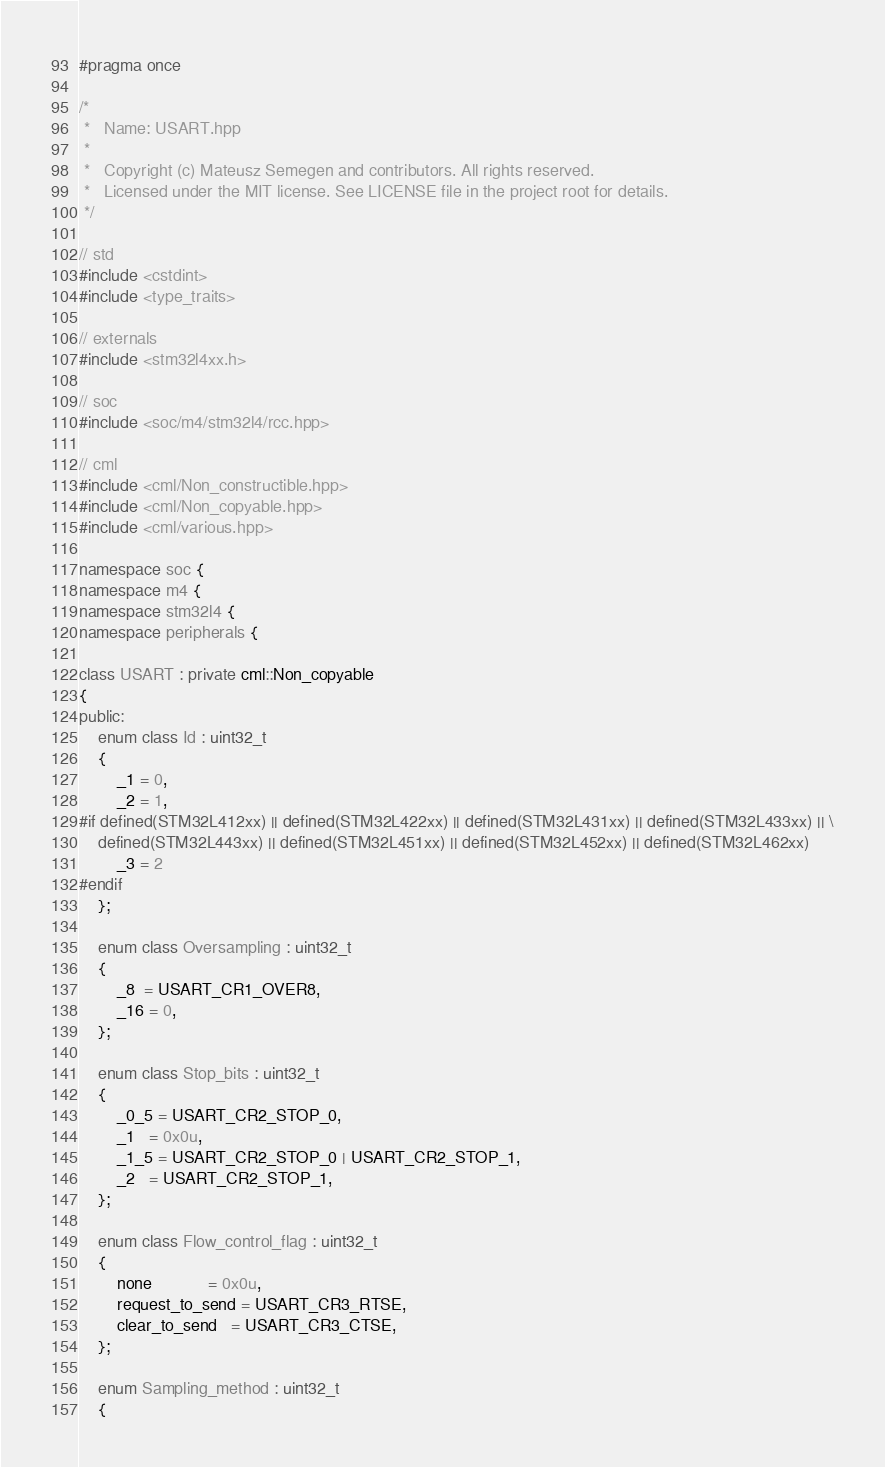Convert code to text. <code><loc_0><loc_0><loc_500><loc_500><_C++_>#pragma once

/*
 *   Name: USART.hpp
 *
 *   Copyright (c) Mateusz Semegen and contributors. All rights reserved.
 *   Licensed under the MIT license. See LICENSE file in the project root for details.
 */

// std
#include <cstdint>
#include <type_traits>

// externals
#include <stm32l4xx.h>

// soc
#include <soc/m4/stm32l4/rcc.hpp>

// cml
#include <cml/Non_constructible.hpp>
#include <cml/Non_copyable.hpp>
#include <cml/various.hpp>

namespace soc {
namespace m4 {
namespace stm32l4 {
namespace peripherals {

class USART : private cml::Non_copyable
{
public:
    enum class Id : uint32_t
    {
        _1 = 0,
        _2 = 1,
#if defined(STM32L412xx) || defined(STM32L422xx) || defined(STM32L431xx) || defined(STM32L433xx) || \
    defined(STM32L443xx) || defined(STM32L451xx) || defined(STM32L452xx) || defined(STM32L462xx)
        _3 = 2
#endif
    };

    enum class Oversampling : uint32_t
    {
        _8  = USART_CR1_OVER8,
        _16 = 0,
    };

    enum class Stop_bits : uint32_t
    {
        _0_5 = USART_CR2_STOP_0,
        _1   = 0x0u,
        _1_5 = USART_CR2_STOP_0 | USART_CR2_STOP_1,
        _2   = USART_CR2_STOP_1,
    };

    enum class Flow_control_flag : uint32_t
    {
        none            = 0x0u,
        request_to_send = USART_CR3_RTSE,
        clear_to_send   = USART_CR3_CTSE,
    };

    enum Sampling_method : uint32_t
    {</code> 